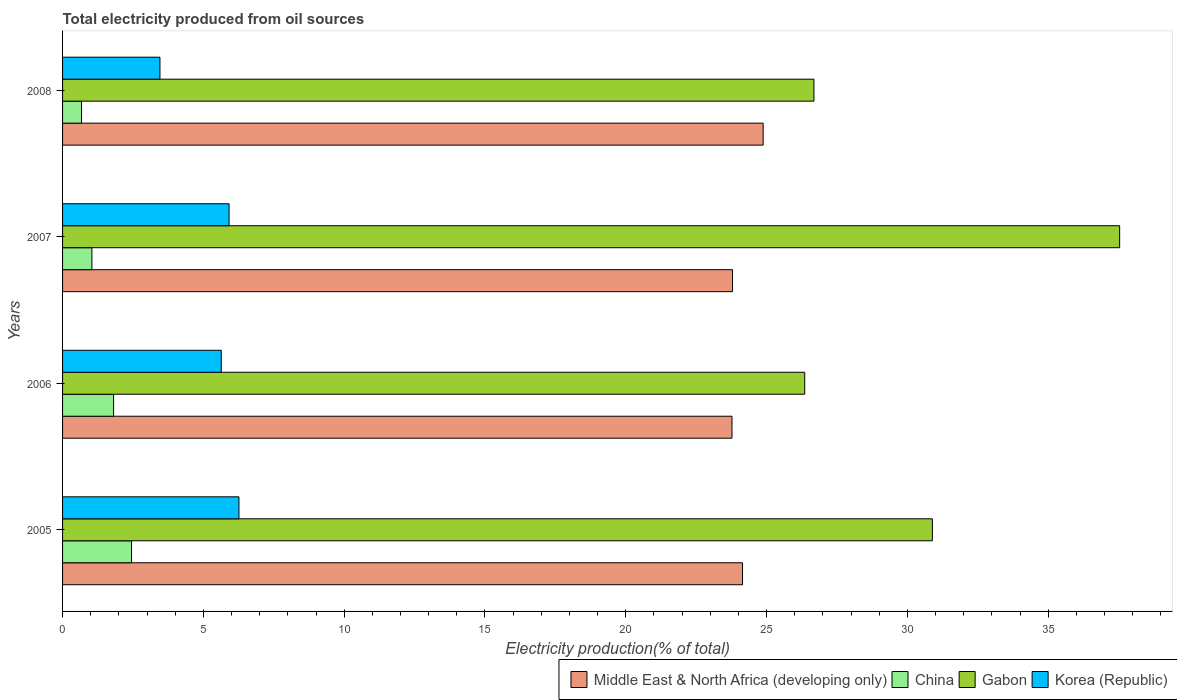How many different coloured bars are there?
Make the answer very short. 4. Are the number of bars on each tick of the Y-axis equal?
Make the answer very short. Yes. How many bars are there on the 1st tick from the top?
Your response must be concise. 4. How many bars are there on the 2nd tick from the bottom?
Offer a terse response. 4. What is the total electricity produced in China in 2007?
Offer a terse response. 1.04. Across all years, what is the maximum total electricity produced in China?
Ensure brevity in your answer.  2.45. Across all years, what is the minimum total electricity produced in Middle East & North Africa (developing only)?
Provide a succinct answer. 23.77. In which year was the total electricity produced in Gabon maximum?
Offer a very short reply. 2007. In which year was the total electricity produced in Korea (Republic) minimum?
Your response must be concise. 2008. What is the total total electricity produced in China in the graph?
Make the answer very short. 5.97. What is the difference between the total electricity produced in China in 2006 and that in 2008?
Give a very brief answer. 1.14. What is the difference between the total electricity produced in Gabon in 2006 and the total electricity produced in Korea (Republic) in 2005?
Offer a very short reply. 20.09. What is the average total electricity produced in Korea (Republic) per year?
Your answer should be compact. 5.32. In the year 2006, what is the difference between the total electricity produced in Middle East & North Africa (developing only) and total electricity produced in Korea (Republic)?
Provide a short and direct response. 18.14. In how many years, is the total electricity produced in Gabon greater than 15 %?
Offer a terse response. 4. What is the ratio of the total electricity produced in Middle East & North Africa (developing only) in 2006 to that in 2007?
Provide a succinct answer. 1. Is the total electricity produced in Middle East & North Africa (developing only) in 2006 less than that in 2007?
Provide a short and direct response. Yes. What is the difference between the highest and the second highest total electricity produced in Korea (Republic)?
Provide a short and direct response. 0.35. What is the difference between the highest and the lowest total electricity produced in Korea (Republic)?
Offer a very short reply. 2.81. Is it the case that in every year, the sum of the total electricity produced in Middle East & North Africa (developing only) and total electricity produced in China is greater than the sum of total electricity produced in Gabon and total electricity produced in Korea (Republic)?
Your answer should be compact. Yes. What does the 4th bar from the top in 2005 represents?
Offer a very short reply. Middle East & North Africa (developing only). How many bars are there?
Your answer should be compact. 16. Are all the bars in the graph horizontal?
Provide a succinct answer. Yes. Does the graph contain grids?
Give a very brief answer. No. How many legend labels are there?
Your answer should be very brief. 4. How are the legend labels stacked?
Make the answer very short. Horizontal. What is the title of the graph?
Your response must be concise. Total electricity produced from oil sources. What is the Electricity production(% of total) of Middle East & North Africa (developing only) in 2005?
Give a very brief answer. 24.14. What is the Electricity production(% of total) of China in 2005?
Your response must be concise. 2.45. What is the Electricity production(% of total) of Gabon in 2005?
Make the answer very short. 30.89. What is the Electricity production(% of total) in Korea (Republic) in 2005?
Give a very brief answer. 6.26. What is the Electricity production(% of total) of Middle East & North Africa (developing only) in 2006?
Provide a short and direct response. 23.77. What is the Electricity production(% of total) in China in 2006?
Your answer should be compact. 1.81. What is the Electricity production(% of total) in Gabon in 2006?
Your response must be concise. 26.35. What is the Electricity production(% of total) of Korea (Republic) in 2006?
Offer a very short reply. 5.63. What is the Electricity production(% of total) in Middle East & North Africa (developing only) in 2007?
Offer a terse response. 23.79. What is the Electricity production(% of total) in China in 2007?
Provide a short and direct response. 1.04. What is the Electricity production(% of total) in Gabon in 2007?
Ensure brevity in your answer.  37.54. What is the Electricity production(% of total) of Korea (Republic) in 2007?
Offer a very short reply. 5.91. What is the Electricity production(% of total) of Middle East & North Africa (developing only) in 2008?
Give a very brief answer. 24.88. What is the Electricity production(% of total) of China in 2008?
Ensure brevity in your answer.  0.67. What is the Electricity production(% of total) in Gabon in 2008?
Provide a succinct answer. 26.68. What is the Electricity production(% of total) in Korea (Republic) in 2008?
Make the answer very short. 3.46. Across all years, what is the maximum Electricity production(% of total) in Middle East & North Africa (developing only)?
Offer a terse response. 24.88. Across all years, what is the maximum Electricity production(% of total) of China?
Offer a very short reply. 2.45. Across all years, what is the maximum Electricity production(% of total) of Gabon?
Keep it short and to the point. 37.54. Across all years, what is the maximum Electricity production(% of total) of Korea (Republic)?
Your answer should be compact. 6.26. Across all years, what is the minimum Electricity production(% of total) in Middle East & North Africa (developing only)?
Provide a succinct answer. 23.77. Across all years, what is the minimum Electricity production(% of total) of China?
Your answer should be very brief. 0.67. Across all years, what is the minimum Electricity production(% of total) in Gabon?
Your answer should be very brief. 26.35. Across all years, what is the minimum Electricity production(% of total) in Korea (Republic)?
Make the answer very short. 3.46. What is the total Electricity production(% of total) of Middle East & North Africa (developing only) in the graph?
Your answer should be compact. 96.58. What is the total Electricity production(% of total) in China in the graph?
Make the answer very short. 5.97. What is the total Electricity production(% of total) in Gabon in the graph?
Keep it short and to the point. 121.46. What is the total Electricity production(% of total) in Korea (Republic) in the graph?
Provide a short and direct response. 21.27. What is the difference between the Electricity production(% of total) of Middle East & North Africa (developing only) in 2005 and that in 2006?
Your answer should be very brief. 0.37. What is the difference between the Electricity production(% of total) of China in 2005 and that in 2006?
Keep it short and to the point. 0.64. What is the difference between the Electricity production(% of total) of Gabon in 2005 and that in 2006?
Make the answer very short. 4.53. What is the difference between the Electricity production(% of total) of Korea (Republic) in 2005 and that in 2006?
Your answer should be very brief. 0.63. What is the difference between the Electricity production(% of total) in Middle East & North Africa (developing only) in 2005 and that in 2007?
Keep it short and to the point. 0.35. What is the difference between the Electricity production(% of total) in China in 2005 and that in 2007?
Provide a short and direct response. 1.41. What is the difference between the Electricity production(% of total) in Gabon in 2005 and that in 2007?
Your answer should be compact. -6.65. What is the difference between the Electricity production(% of total) in Korea (Republic) in 2005 and that in 2007?
Give a very brief answer. 0.35. What is the difference between the Electricity production(% of total) of Middle East & North Africa (developing only) in 2005 and that in 2008?
Make the answer very short. -0.73. What is the difference between the Electricity production(% of total) of China in 2005 and that in 2008?
Ensure brevity in your answer.  1.78. What is the difference between the Electricity production(% of total) of Gabon in 2005 and that in 2008?
Give a very brief answer. 4.21. What is the difference between the Electricity production(% of total) in Korea (Republic) in 2005 and that in 2008?
Keep it short and to the point. 2.81. What is the difference between the Electricity production(% of total) in Middle East & North Africa (developing only) in 2006 and that in 2007?
Make the answer very short. -0.02. What is the difference between the Electricity production(% of total) in China in 2006 and that in 2007?
Ensure brevity in your answer.  0.77. What is the difference between the Electricity production(% of total) of Gabon in 2006 and that in 2007?
Offer a terse response. -11.18. What is the difference between the Electricity production(% of total) in Korea (Republic) in 2006 and that in 2007?
Your answer should be very brief. -0.28. What is the difference between the Electricity production(% of total) of Middle East & North Africa (developing only) in 2006 and that in 2008?
Give a very brief answer. -1.11. What is the difference between the Electricity production(% of total) in China in 2006 and that in 2008?
Provide a short and direct response. 1.14. What is the difference between the Electricity production(% of total) of Gabon in 2006 and that in 2008?
Give a very brief answer. -0.33. What is the difference between the Electricity production(% of total) in Korea (Republic) in 2006 and that in 2008?
Give a very brief answer. 2.18. What is the difference between the Electricity production(% of total) in Middle East & North Africa (developing only) in 2007 and that in 2008?
Make the answer very short. -1.09. What is the difference between the Electricity production(% of total) in China in 2007 and that in 2008?
Offer a terse response. 0.37. What is the difference between the Electricity production(% of total) of Gabon in 2007 and that in 2008?
Keep it short and to the point. 10.85. What is the difference between the Electricity production(% of total) of Korea (Republic) in 2007 and that in 2008?
Ensure brevity in your answer.  2.45. What is the difference between the Electricity production(% of total) of Middle East & North Africa (developing only) in 2005 and the Electricity production(% of total) of China in 2006?
Make the answer very short. 22.33. What is the difference between the Electricity production(% of total) in Middle East & North Africa (developing only) in 2005 and the Electricity production(% of total) in Gabon in 2006?
Your response must be concise. -2.21. What is the difference between the Electricity production(% of total) in Middle East & North Africa (developing only) in 2005 and the Electricity production(% of total) in Korea (Republic) in 2006?
Your answer should be very brief. 18.51. What is the difference between the Electricity production(% of total) in China in 2005 and the Electricity production(% of total) in Gabon in 2006?
Ensure brevity in your answer.  -23.91. What is the difference between the Electricity production(% of total) in China in 2005 and the Electricity production(% of total) in Korea (Republic) in 2006?
Offer a terse response. -3.19. What is the difference between the Electricity production(% of total) in Gabon in 2005 and the Electricity production(% of total) in Korea (Republic) in 2006?
Provide a short and direct response. 25.25. What is the difference between the Electricity production(% of total) of Middle East & North Africa (developing only) in 2005 and the Electricity production(% of total) of China in 2007?
Provide a succinct answer. 23.1. What is the difference between the Electricity production(% of total) in Middle East & North Africa (developing only) in 2005 and the Electricity production(% of total) in Gabon in 2007?
Your response must be concise. -13.39. What is the difference between the Electricity production(% of total) of Middle East & North Africa (developing only) in 2005 and the Electricity production(% of total) of Korea (Republic) in 2007?
Offer a terse response. 18.23. What is the difference between the Electricity production(% of total) in China in 2005 and the Electricity production(% of total) in Gabon in 2007?
Provide a short and direct response. -35.09. What is the difference between the Electricity production(% of total) of China in 2005 and the Electricity production(% of total) of Korea (Republic) in 2007?
Your answer should be compact. -3.46. What is the difference between the Electricity production(% of total) in Gabon in 2005 and the Electricity production(% of total) in Korea (Republic) in 2007?
Your answer should be compact. 24.97. What is the difference between the Electricity production(% of total) in Middle East & North Africa (developing only) in 2005 and the Electricity production(% of total) in China in 2008?
Your response must be concise. 23.47. What is the difference between the Electricity production(% of total) in Middle East & North Africa (developing only) in 2005 and the Electricity production(% of total) in Gabon in 2008?
Ensure brevity in your answer.  -2.54. What is the difference between the Electricity production(% of total) of Middle East & North Africa (developing only) in 2005 and the Electricity production(% of total) of Korea (Republic) in 2008?
Offer a very short reply. 20.69. What is the difference between the Electricity production(% of total) in China in 2005 and the Electricity production(% of total) in Gabon in 2008?
Keep it short and to the point. -24.23. What is the difference between the Electricity production(% of total) of China in 2005 and the Electricity production(% of total) of Korea (Republic) in 2008?
Your response must be concise. -1.01. What is the difference between the Electricity production(% of total) in Gabon in 2005 and the Electricity production(% of total) in Korea (Republic) in 2008?
Provide a succinct answer. 27.43. What is the difference between the Electricity production(% of total) in Middle East & North Africa (developing only) in 2006 and the Electricity production(% of total) in China in 2007?
Keep it short and to the point. 22.73. What is the difference between the Electricity production(% of total) of Middle East & North Africa (developing only) in 2006 and the Electricity production(% of total) of Gabon in 2007?
Your answer should be very brief. -13.77. What is the difference between the Electricity production(% of total) in Middle East & North Africa (developing only) in 2006 and the Electricity production(% of total) in Korea (Republic) in 2007?
Give a very brief answer. 17.86. What is the difference between the Electricity production(% of total) of China in 2006 and the Electricity production(% of total) of Gabon in 2007?
Keep it short and to the point. -35.72. What is the difference between the Electricity production(% of total) of China in 2006 and the Electricity production(% of total) of Korea (Republic) in 2007?
Your response must be concise. -4.1. What is the difference between the Electricity production(% of total) in Gabon in 2006 and the Electricity production(% of total) in Korea (Republic) in 2007?
Keep it short and to the point. 20.44. What is the difference between the Electricity production(% of total) of Middle East & North Africa (developing only) in 2006 and the Electricity production(% of total) of China in 2008?
Provide a succinct answer. 23.1. What is the difference between the Electricity production(% of total) of Middle East & North Africa (developing only) in 2006 and the Electricity production(% of total) of Gabon in 2008?
Keep it short and to the point. -2.91. What is the difference between the Electricity production(% of total) in Middle East & North Africa (developing only) in 2006 and the Electricity production(% of total) in Korea (Republic) in 2008?
Give a very brief answer. 20.31. What is the difference between the Electricity production(% of total) of China in 2006 and the Electricity production(% of total) of Gabon in 2008?
Your answer should be very brief. -24.87. What is the difference between the Electricity production(% of total) of China in 2006 and the Electricity production(% of total) of Korea (Republic) in 2008?
Give a very brief answer. -1.65. What is the difference between the Electricity production(% of total) of Gabon in 2006 and the Electricity production(% of total) of Korea (Republic) in 2008?
Your response must be concise. 22.9. What is the difference between the Electricity production(% of total) in Middle East & North Africa (developing only) in 2007 and the Electricity production(% of total) in China in 2008?
Provide a succinct answer. 23.12. What is the difference between the Electricity production(% of total) in Middle East & North Africa (developing only) in 2007 and the Electricity production(% of total) in Gabon in 2008?
Your response must be concise. -2.89. What is the difference between the Electricity production(% of total) in Middle East & North Africa (developing only) in 2007 and the Electricity production(% of total) in Korea (Republic) in 2008?
Make the answer very short. 20.33. What is the difference between the Electricity production(% of total) in China in 2007 and the Electricity production(% of total) in Gabon in 2008?
Give a very brief answer. -25.64. What is the difference between the Electricity production(% of total) of China in 2007 and the Electricity production(% of total) of Korea (Republic) in 2008?
Your answer should be very brief. -2.42. What is the difference between the Electricity production(% of total) in Gabon in 2007 and the Electricity production(% of total) in Korea (Republic) in 2008?
Give a very brief answer. 34.08. What is the average Electricity production(% of total) of Middle East & North Africa (developing only) per year?
Give a very brief answer. 24.15. What is the average Electricity production(% of total) in China per year?
Provide a succinct answer. 1.49. What is the average Electricity production(% of total) of Gabon per year?
Your response must be concise. 30.36. What is the average Electricity production(% of total) of Korea (Republic) per year?
Offer a very short reply. 5.32. In the year 2005, what is the difference between the Electricity production(% of total) of Middle East & North Africa (developing only) and Electricity production(% of total) of China?
Keep it short and to the point. 21.7. In the year 2005, what is the difference between the Electricity production(% of total) in Middle East & North Africa (developing only) and Electricity production(% of total) in Gabon?
Ensure brevity in your answer.  -6.74. In the year 2005, what is the difference between the Electricity production(% of total) in Middle East & North Africa (developing only) and Electricity production(% of total) in Korea (Republic)?
Keep it short and to the point. 17.88. In the year 2005, what is the difference between the Electricity production(% of total) in China and Electricity production(% of total) in Gabon?
Ensure brevity in your answer.  -28.44. In the year 2005, what is the difference between the Electricity production(% of total) of China and Electricity production(% of total) of Korea (Republic)?
Your answer should be compact. -3.82. In the year 2005, what is the difference between the Electricity production(% of total) of Gabon and Electricity production(% of total) of Korea (Republic)?
Offer a terse response. 24.62. In the year 2006, what is the difference between the Electricity production(% of total) in Middle East & North Africa (developing only) and Electricity production(% of total) in China?
Keep it short and to the point. 21.96. In the year 2006, what is the difference between the Electricity production(% of total) of Middle East & North Africa (developing only) and Electricity production(% of total) of Gabon?
Provide a succinct answer. -2.58. In the year 2006, what is the difference between the Electricity production(% of total) in Middle East & North Africa (developing only) and Electricity production(% of total) in Korea (Republic)?
Ensure brevity in your answer.  18.14. In the year 2006, what is the difference between the Electricity production(% of total) in China and Electricity production(% of total) in Gabon?
Keep it short and to the point. -24.54. In the year 2006, what is the difference between the Electricity production(% of total) of China and Electricity production(% of total) of Korea (Republic)?
Make the answer very short. -3.82. In the year 2006, what is the difference between the Electricity production(% of total) in Gabon and Electricity production(% of total) in Korea (Republic)?
Your response must be concise. 20.72. In the year 2007, what is the difference between the Electricity production(% of total) of Middle East & North Africa (developing only) and Electricity production(% of total) of China?
Your response must be concise. 22.75. In the year 2007, what is the difference between the Electricity production(% of total) in Middle East & North Africa (developing only) and Electricity production(% of total) in Gabon?
Offer a very short reply. -13.75. In the year 2007, what is the difference between the Electricity production(% of total) of Middle East & North Africa (developing only) and Electricity production(% of total) of Korea (Republic)?
Ensure brevity in your answer.  17.88. In the year 2007, what is the difference between the Electricity production(% of total) of China and Electricity production(% of total) of Gabon?
Your answer should be very brief. -36.49. In the year 2007, what is the difference between the Electricity production(% of total) in China and Electricity production(% of total) in Korea (Republic)?
Keep it short and to the point. -4.87. In the year 2007, what is the difference between the Electricity production(% of total) in Gabon and Electricity production(% of total) in Korea (Republic)?
Give a very brief answer. 31.62. In the year 2008, what is the difference between the Electricity production(% of total) of Middle East & North Africa (developing only) and Electricity production(% of total) of China?
Offer a terse response. 24.2. In the year 2008, what is the difference between the Electricity production(% of total) in Middle East & North Africa (developing only) and Electricity production(% of total) in Gabon?
Your response must be concise. -1.8. In the year 2008, what is the difference between the Electricity production(% of total) in Middle East & North Africa (developing only) and Electricity production(% of total) in Korea (Republic)?
Keep it short and to the point. 21.42. In the year 2008, what is the difference between the Electricity production(% of total) in China and Electricity production(% of total) in Gabon?
Provide a succinct answer. -26.01. In the year 2008, what is the difference between the Electricity production(% of total) in China and Electricity production(% of total) in Korea (Republic)?
Make the answer very short. -2.79. In the year 2008, what is the difference between the Electricity production(% of total) in Gabon and Electricity production(% of total) in Korea (Republic)?
Give a very brief answer. 23.22. What is the ratio of the Electricity production(% of total) of Middle East & North Africa (developing only) in 2005 to that in 2006?
Your answer should be very brief. 1.02. What is the ratio of the Electricity production(% of total) of China in 2005 to that in 2006?
Ensure brevity in your answer.  1.35. What is the ratio of the Electricity production(% of total) of Gabon in 2005 to that in 2006?
Offer a terse response. 1.17. What is the ratio of the Electricity production(% of total) of Korea (Republic) in 2005 to that in 2006?
Offer a very short reply. 1.11. What is the ratio of the Electricity production(% of total) in Middle East & North Africa (developing only) in 2005 to that in 2007?
Provide a succinct answer. 1.01. What is the ratio of the Electricity production(% of total) of China in 2005 to that in 2007?
Offer a terse response. 2.35. What is the ratio of the Electricity production(% of total) in Gabon in 2005 to that in 2007?
Provide a succinct answer. 0.82. What is the ratio of the Electricity production(% of total) in Korea (Republic) in 2005 to that in 2007?
Your answer should be compact. 1.06. What is the ratio of the Electricity production(% of total) of Middle East & North Africa (developing only) in 2005 to that in 2008?
Offer a very short reply. 0.97. What is the ratio of the Electricity production(% of total) in China in 2005 to that in 2008?
Provide a short and direct response. 3.64. What is the ratio of the Electricity production(% of total) of Gabon in 2005 to that in 2008?
Your response must be concise. 1.16. What is the ratio of the Electricity production(% of total) in Korea (Republic) in 2005 to that in 2008?
Provide a short and direct response. 1.81. What is the ratio of the Electricity production(% of total) of Middle East & North Africa (developing only) in 2006 to that in 2007?
Make the answer very short. 1. What is the ratio of the Electricity production(% of total) in China in 2006 to that in 2007?
Keep it short and to the point. 1.74. What is the ratio of the Electricity production(% of total) of Gabon in 2006 to that in 2007?
Ensure brevity in your answer.  0.7. What is the ratio of the Electricity production(% of total) in Korea (Republic) in 2006 to that in 2007?
Offer a very short reply. 0.95. What is the ratio of the Electricity production(% of total) of Middle East & North Africa (developing only) in 2006 to that in 2008?
Make the answer very short. 0.96. What is the ratio of the Electricity production(% of total) in China in 2006 to that in 2008?
Your answer should be very brief. 2.69. What is the ratio of the Electricity production(% of total) in Gabon in 2006 to that in 2008?
Ensure brevity in your answer.  0.99. What is the ratio of the Electricity production(% of total) of Korea (Republic) in 2006 to that in 2008?
Provide a short and direct response. 1.63. What is the ratio of the Electricity production(% of total) in Middle East & North Africa (developing only) in 2007 to that in 2008?
Keep it short and to the point. 0.96. What is the ratio of the Electricity production(% of total) in China in 2007 to that in 2008?
Provide a succinct answer. 1.55. What is the ratio of the Electricity production(% of total) of Gabon in 2007 to that in 2008?
Your response must be concise. 1.41. What is the ratio of the Electricity production(% of total) of Korea (Republic) in 2007 to that in 2008?
Offer a very short reply. 1.71. What is the difference between the highest and the second highest Electricity production(% of total) of Middle East & North Africa (developing only)?
Your answer should be compact. 0.73. What is the difference between the highest and the second highest Electricity production(% of total) of China?
Make the answer very short. 0.64. What is the difference between the highest and the second highest Electricity production(% of total) in Gabon?
Offer a terse response. 6.65. What is the difference between the highest and the second highest Electricity production(% of total) in Korea (Republic)?
Offer a very short reply. 0.35. What is the difference between the highest and the lowest Electricity production(% of total) of Middle East & North Africa (developing only)?
Offer a very short reply. 1.11. What is the difference between the highest and the lowest Electricity production(% of total) of China?
Give a very brief answer. 1.78. What is the difference between the highest and the lowest Electricity production(% of total) of Gabon?
Ensure brevity in your answer.  11.18. What is the difference between the highest and the lowest Electricity production(% of total) of Korea (Republic)?
Provide a succinct answer. 2.81. 